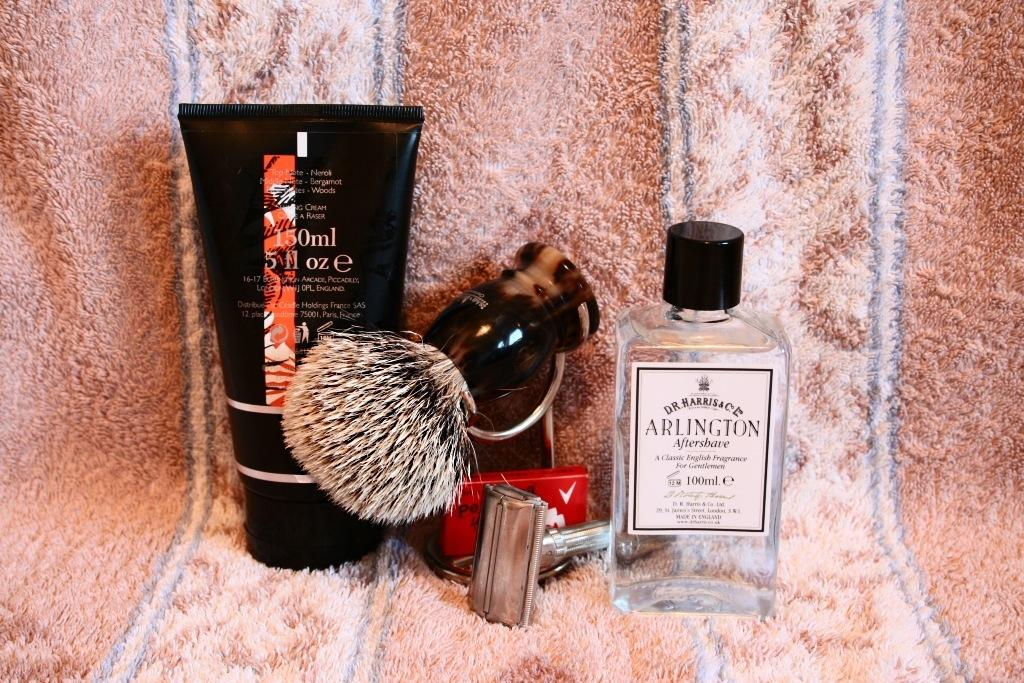<image>
Relay a brief, clear account of the picture shown. the name Arlington is on the clear glass 